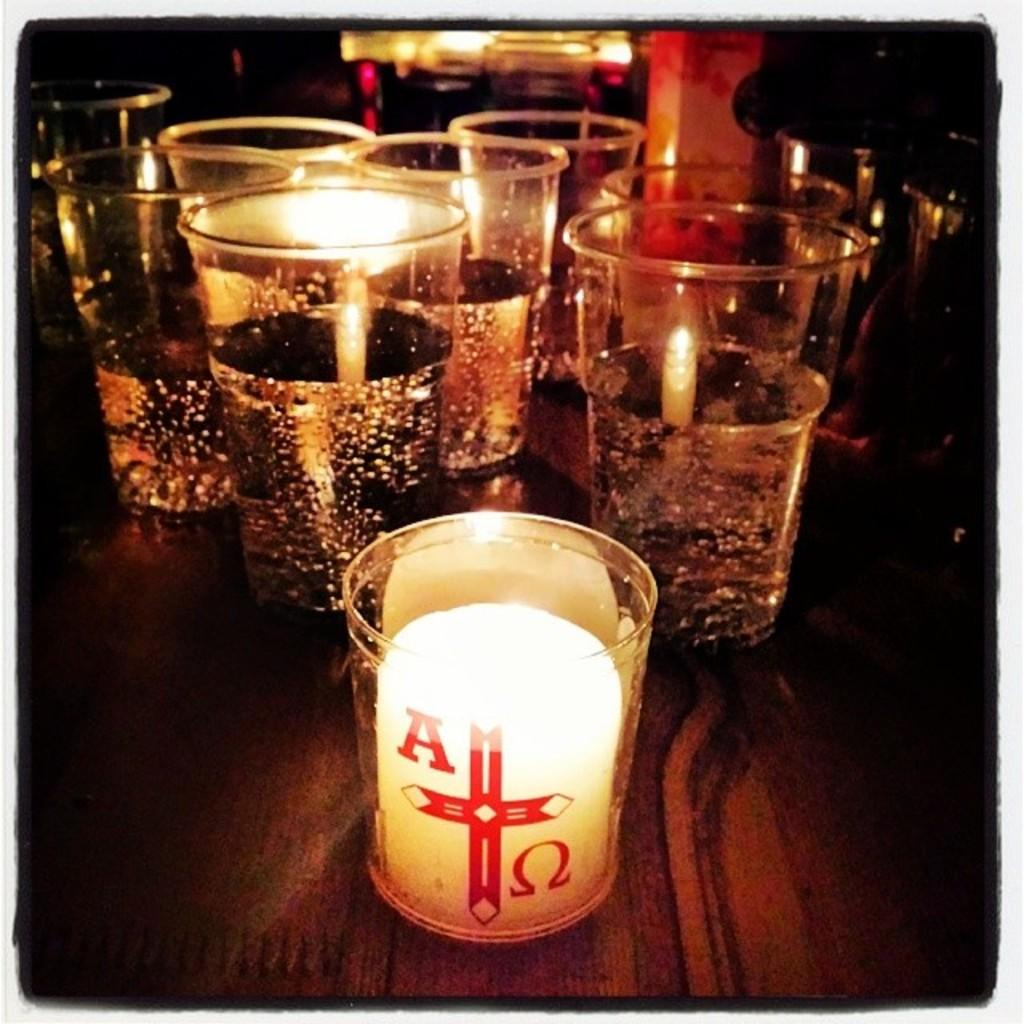Provide a one-sentence caption for the provided image. A candle lite in a glass with A red cross in the middle with 6 more candles in the back. 